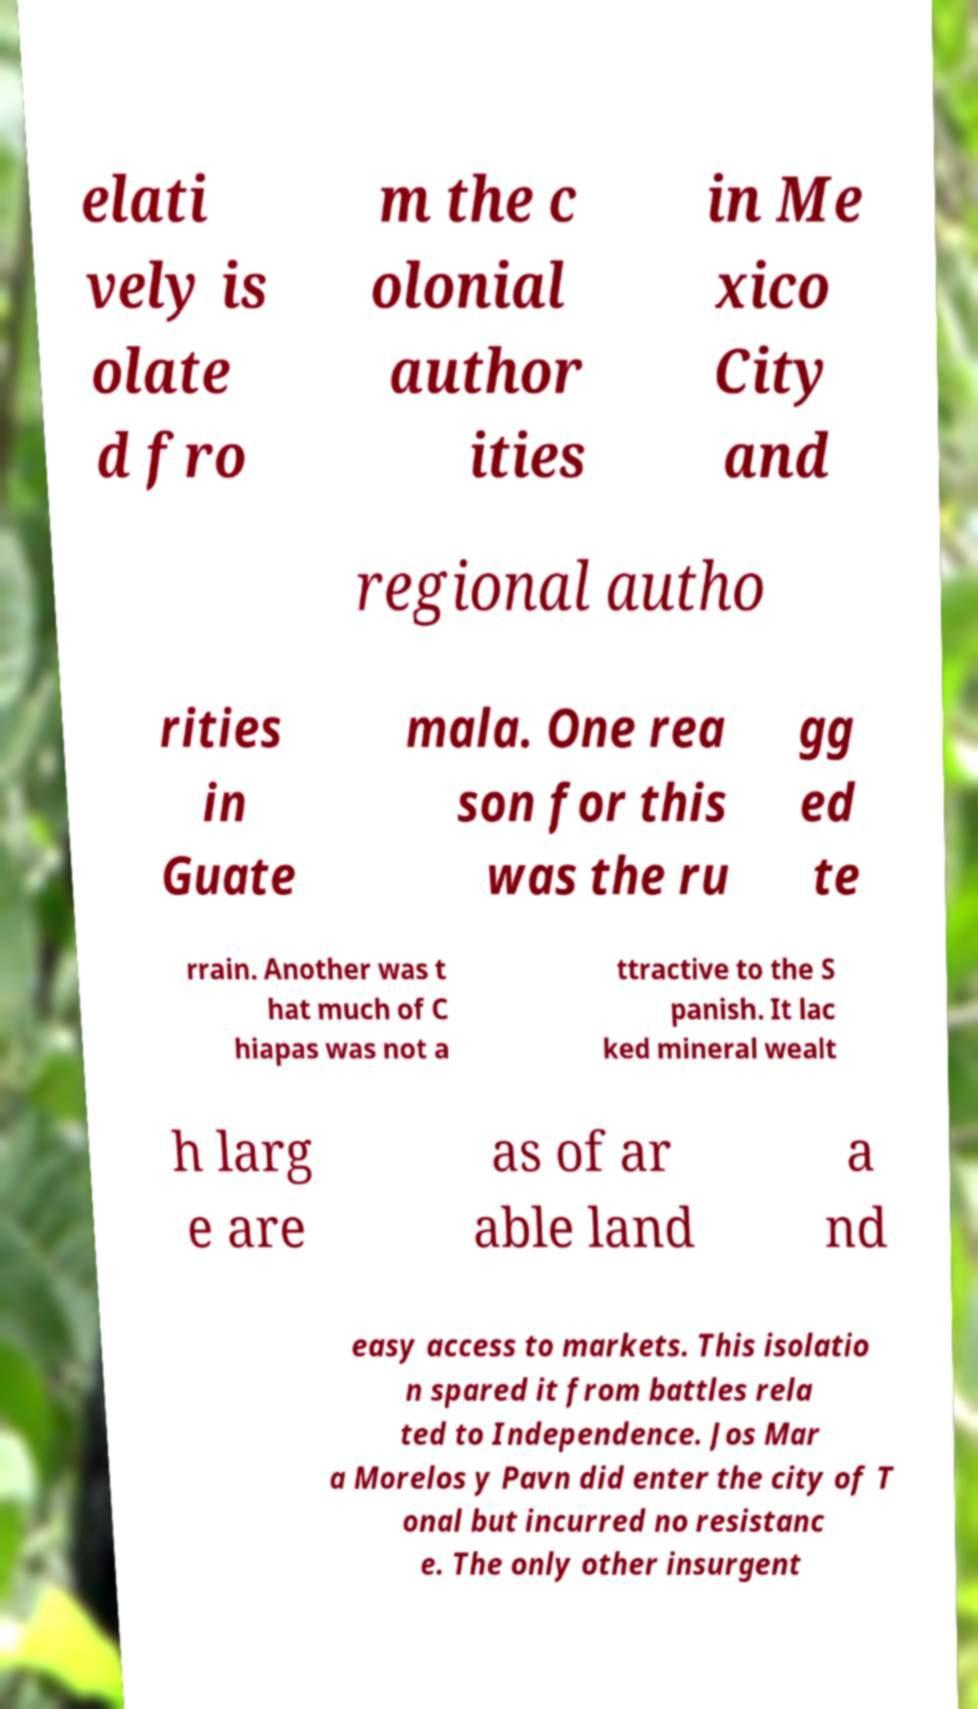Can you read and provide the text displayed in the image?This photo seems to have some interesting text. Can you extract and type it out for me? elati vely is olate d fro m the c olonial author ities in Me xico City and regional autho rities in Guate mala. One rea son for this was the ru gg ed te rrain. Another was t hat much of C hiapas was not a ttractive to the S panish. It lac ked mineral wealt h larg e are as of ar able land a nd easy access to markets. This isolatio n spared it from battles rela ted to Independence. Jos Mar a Morelos y Pavn did enter the city of T onal but incurred no resistanc e. The only other insurgent 